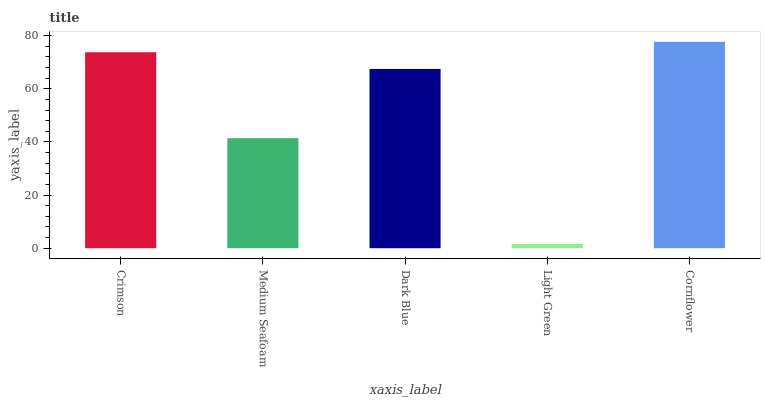Is Light Green the minimum?
Answer yes or no. Yes. Is Cornflower the maximum?
Answer yes or no. Yes. Is Medium Seafoam the minimum?
Answer yes or no. No. Is Medium Seafoam the maximum?
Answer yes or no. No. Is Crimson greater than Medium Seafoam?
Answer yes or no. Yes. Is Medium Seafoam less than Crimson?
Answer yes or no. Yes. Is Medium Seafoam greater than Crimson?
Answer yes or no. No. Is Crimson less than Medium Seafoam?
Answer yes or no. No. Is Dark Blue the high median?
Answer yes or no. Yes. Is Dark Blue the low median?
Answer yes or no. Yes. Is Light Green the high median?
Answer yes or no. No. Is Cornflower the low median?
Answer yes or no. No. 